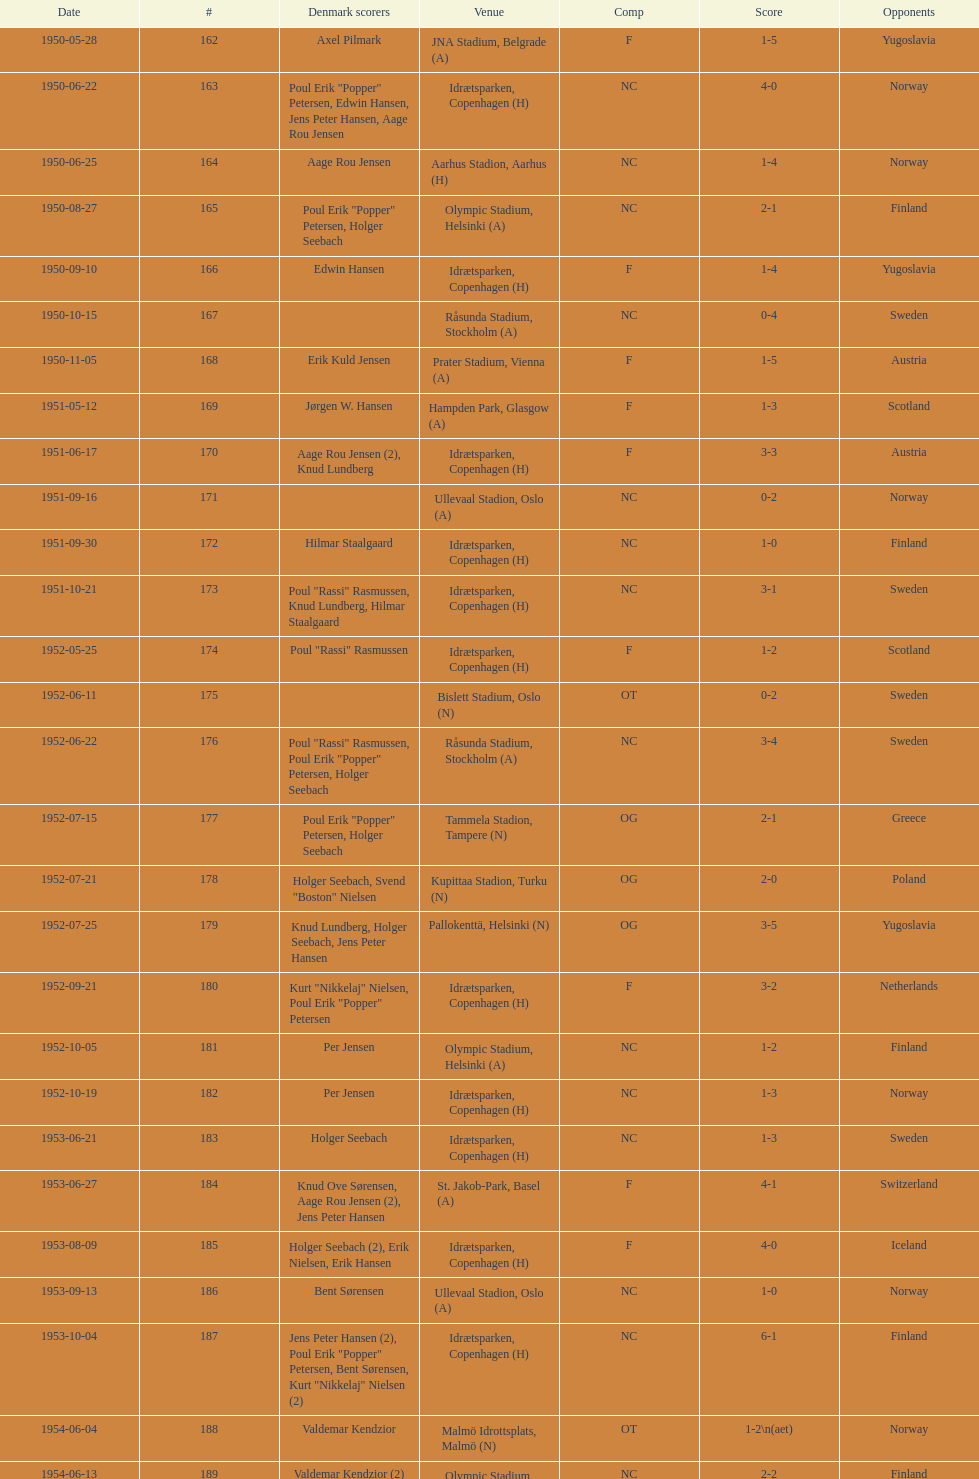What is the name of the venue listed before olympic stadium on 1950-08-27? Aarhus Stadion, Aarhus. 